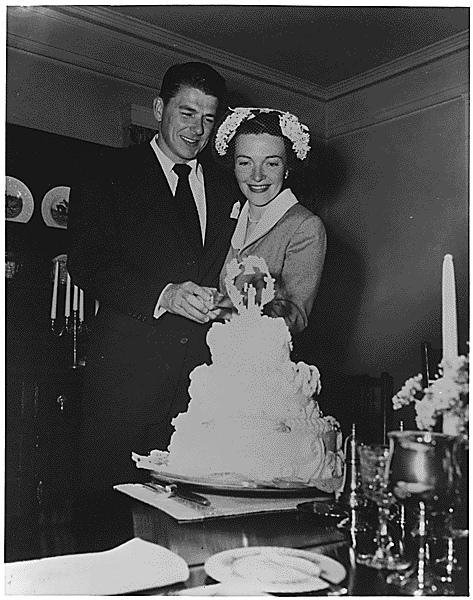Does the couple appear to be young?
Answer briefly. Yes. What event is depicted?
Keep it brief. Wedding. Does the woman wear these hair accessories every day?
Write a very short answer. No. 